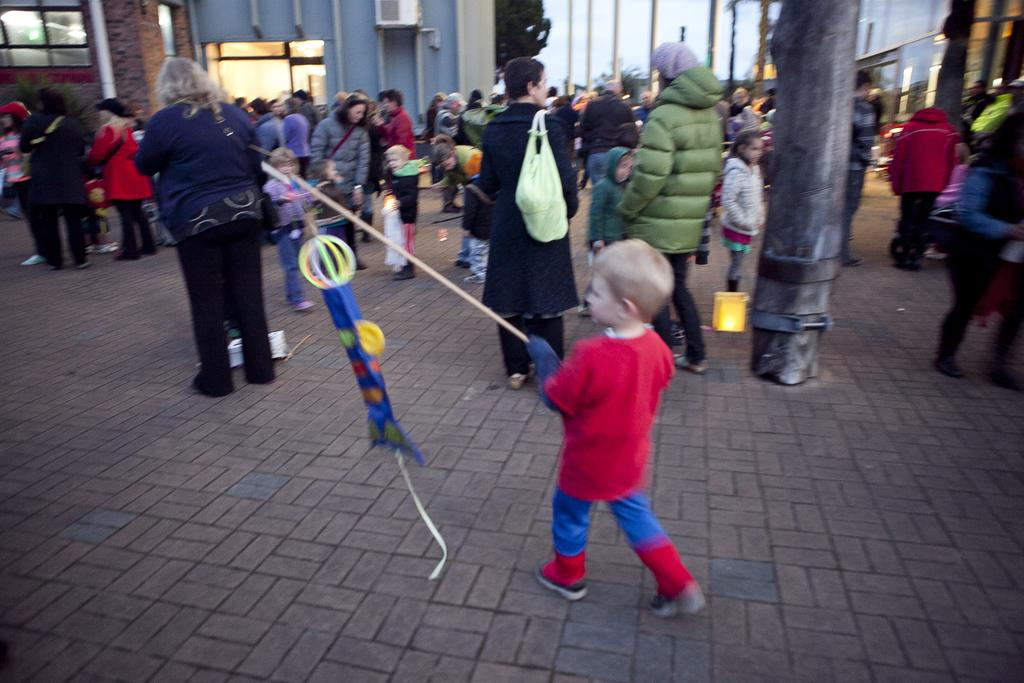How many people are present in the image? There are many people in the image. What are the people wearing in the image? The people are wearing jackets. Where are the people standing in the image? The people are standing on the land. What can be seen in the background of the image? There are buildings in the background of the image. On which side of the image are the buildings located? The buildings are on the left side of the image. What is present behind the buildings on the left side? There is a tree behind the buildings on the left side. What type of produce is being harvested by the people in the image? There is no produce being harvested in the image; the people are wearing jackets and standing on the land. What is the tendency of the mountain in the image? There is no mountain present in the image, so it is not possible to determine its tendency. 